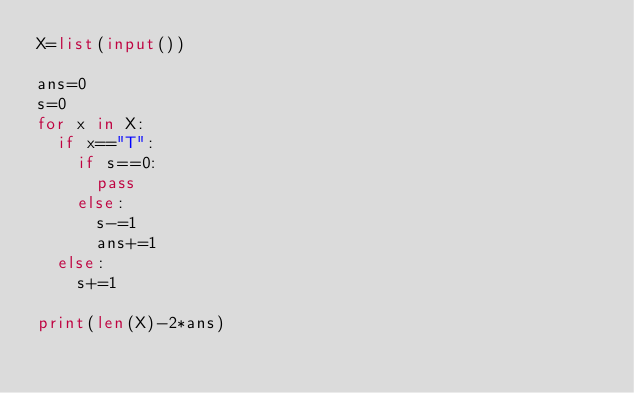<code> <loc_0><loc_0><loc_500><loc_500><_Python_>X=list(input())

ans=0
s=0
for x in X:
  if x=="T":
    if s==0:
      pass
    else:
      s-=1
      ans+=1
  else:
    s+=1
    
print(len(X)-2*ans)</code> 